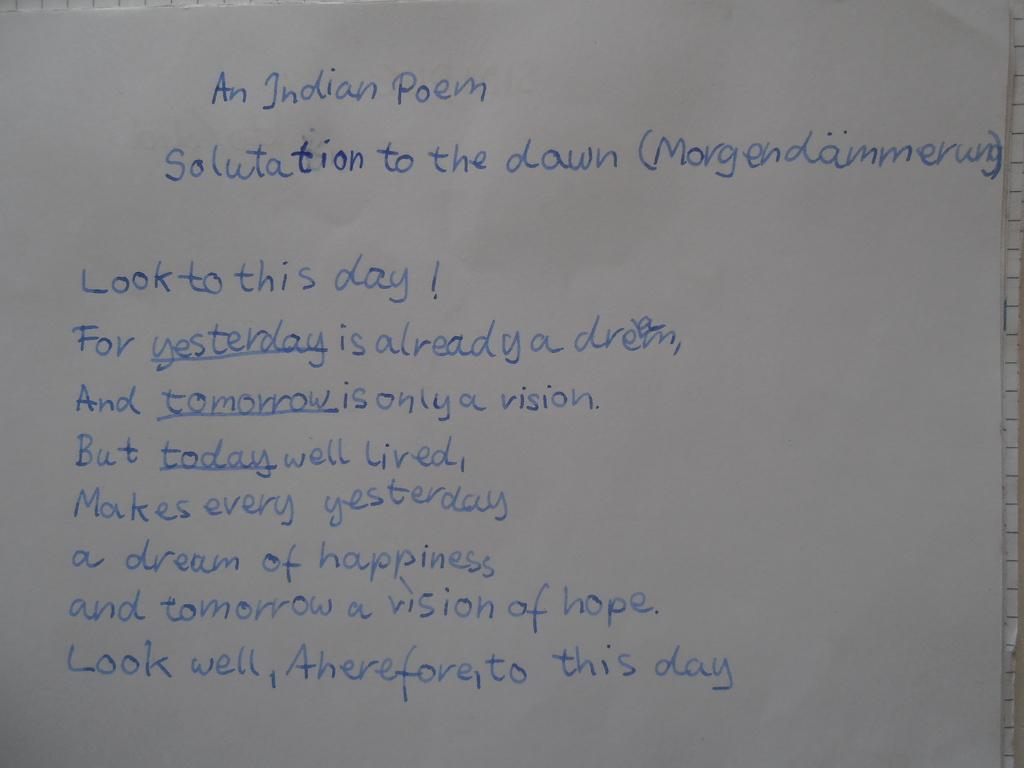What is the first line at the top of the text?
Provide a succinct answer. An indian poem. 